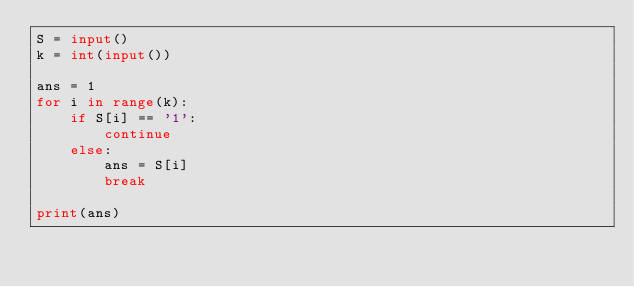Convert code to text. <code><loc_0><loc_0><loc_500><loc_500><_Python_>S = input()
k = int(input())

ans = 1
for i in range(k):
    if S[i] == '1':
        continue
    else:
        ans = S[i]
        break
        
print(ans)</code> 